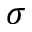Convert formula to latex. <formula><loc_0><loc_0><loc_500><loc_500>\sigma</formula> 